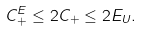<formula> <loc_0><loc_0><loc_500><loc_500>C _ { + } ^ { E } \leq 2 C _ { + } \leq 2 E _ { U } .</formula> 